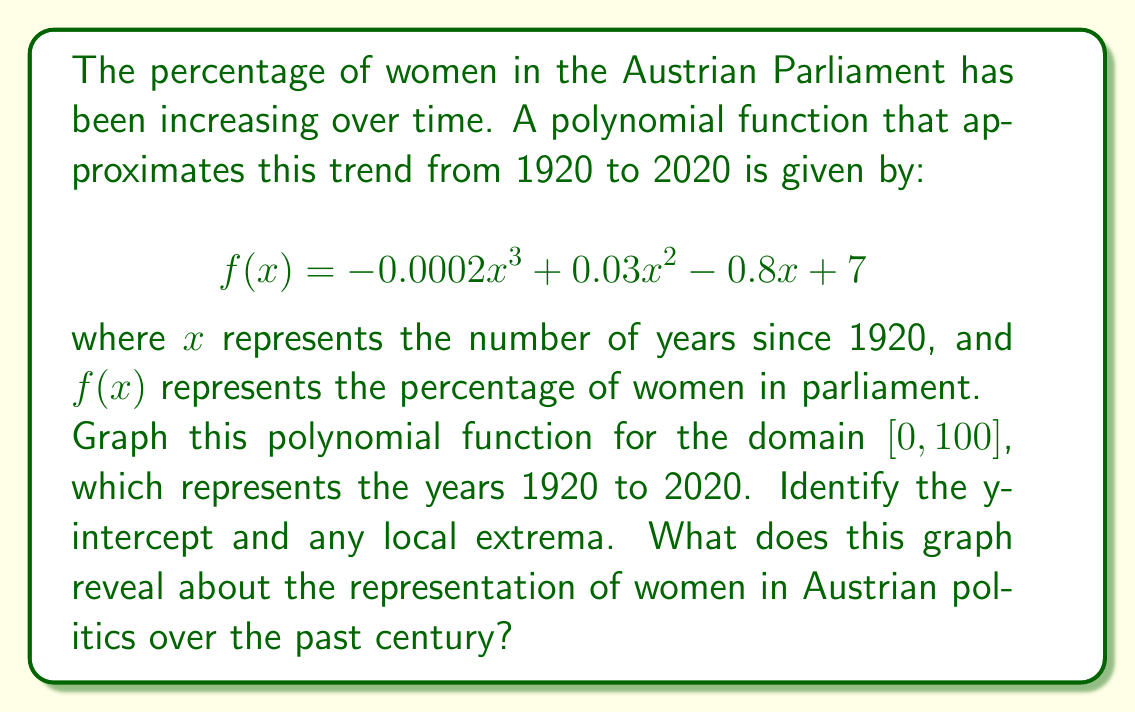Provide a solution to this math problem. To graph the polynomial function and analyze its features:

1. Set up the graph:
   - x-axis: 0 to 100 (representing years 1920 to 2020)
   - y-axis: 0 to 40 (percentage of women in parliament)

2. Plot the function:
   $f(x) = -0.0002x^3 + 0.03x^2 - 0.8x + 7$

3. Identify the y-intercept:
   When $x = 0$ (year 1920), $f(0) = 7$
   The y-intercept is (0, 7), meaning 7% women in 1920.

4. Find local extrema:
   Take the derivative: $f'(x) = -0.0006x^2 + 0.06x - 0.8$
   Set $f'(x) = 0$ and solve:
   $-0.0006x^2 + 0.06x - 0.8 = 0$
   $x \approx 16.7$ or $x \approx 83.3$

   Check second derivative:
   $f''(x) = -0.0012x + 0.06$
   At $x = 16.7$, $f''(16.7) > 0$ (local minimum)
   At $x = 83.3$, $f''(83.3) < 0$ (local maximum)

   Local minimum: (16.7, 3.1) around 1937
   Local maximum: (83.3, 37.4) around 2003

5. Interpret the graph:
   - Started at 7% in 1920
   - Decreased to a minimum of 3.1% around 1937
   - Steadily increased after that
   - Reached a maximum of 37.4% around 2003
   - Slight decrease towards 2020

This graph shows that women's representation in Austrian parliament started low, decreased in the early years, then significantly increased over the latter part of the century, with a slight decline in recent years.

[asy]
import graph;
size(300,200);

real f(real x) {return -0.0002x^3 + 0.03x^2 - 0.8x + 7;}

draw(graph(f,0,100),blue);

xaxis("Years since 1920",0,100,Arrow);
yaxis("Percentage of women",0,40,Arrow);

dot((0,7),red);
dot((16.7,f(16.7)),red);
dot((83.3,f(83.3)),red);

label("1920",(0,-2),S);
label("1970",(50,-2),S);
label("2020",(100,-2),S);

label("7%",(0,7),W);
label("Min",(16.7,f(16.7)),SW);
label("Max",(83.3,f(83.3)),NE);
[/asy]
Answer: The graph shows a cubic function starting at (0, 7), with a local minimum around (16.7, 3.1) and a local maximum around (83.3, 37.4). It reveals that women's representation in Austrian parliament started at 7% in 1920, decreased to about 3.1% in the late 1930s, then steadily increased to a peak of about 37.4% in the early 2000s, followed by a slight decline towards 2020. 